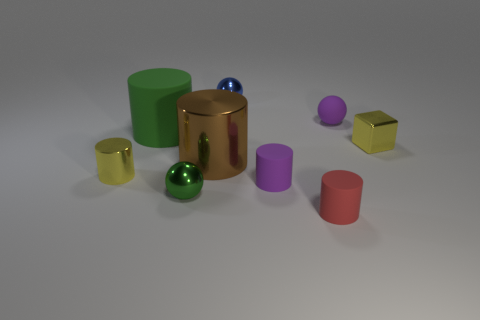There is a shiny cylinder to the left of the brown object; is it the same size as the green ball?
Provide a succinct answer. Yes. There is a yellow block that is the same size as the red object; what is it made of?
Your response must be concise. Metal. There is a small blue metallic object that is behind the metal cylinder that is to the right of the tiny green sphere; are there any tiny blue metal balls on the left side of it?
Keep it short and to the point. No. Are there any other things that are the same shape as the tiny red rubber object?
Your response must be concise. Yes. Is the color of the object on the left side of the green rubber cylinder the same as the small ball that is in front of the large matte thing?
Your answer should be very brief. No. Is there a tiny shiny sphere?
Provide a short and direct response. Yes. What is the material of the cylinder that is the same color as the tiny block?
Your response must be concise. Metal. There is a yellow shiny thing that is right of the tiny matte object that is left of the red cylinder right of the big green matte thing; what is its size?
Offer a terse response. Small. There is a small green object; is its shape the same as the tiny yellow metallic object behind the yellow metal cylinder?
Your answer should be compact. No. Are there any blocks that have the same color as the big matte thing?
Your response must be concise. No. 